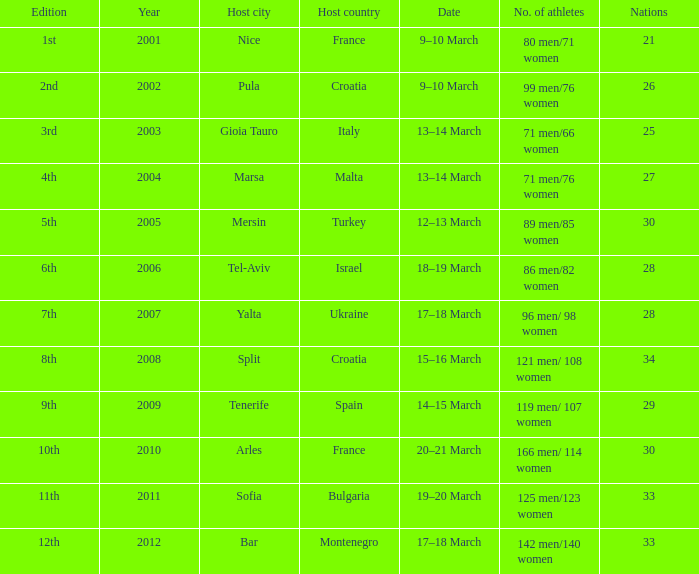Montenegro hosted in what year? 2012.0. 